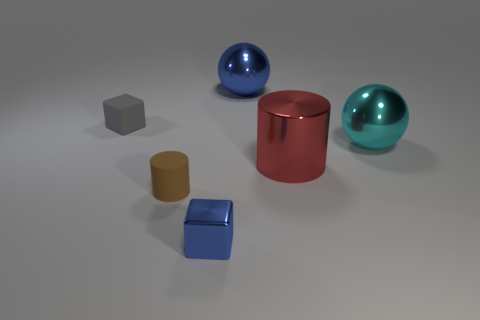Could you describe the lighting and shadows in the scene? The lighting in the scene is soft and diffuse, coming from above as indicated by the gentle shadows cast directly underneath each object. These muted shadows suggest an ambient light source, potentially indoors, that creates a serene and evenly lit setting. 